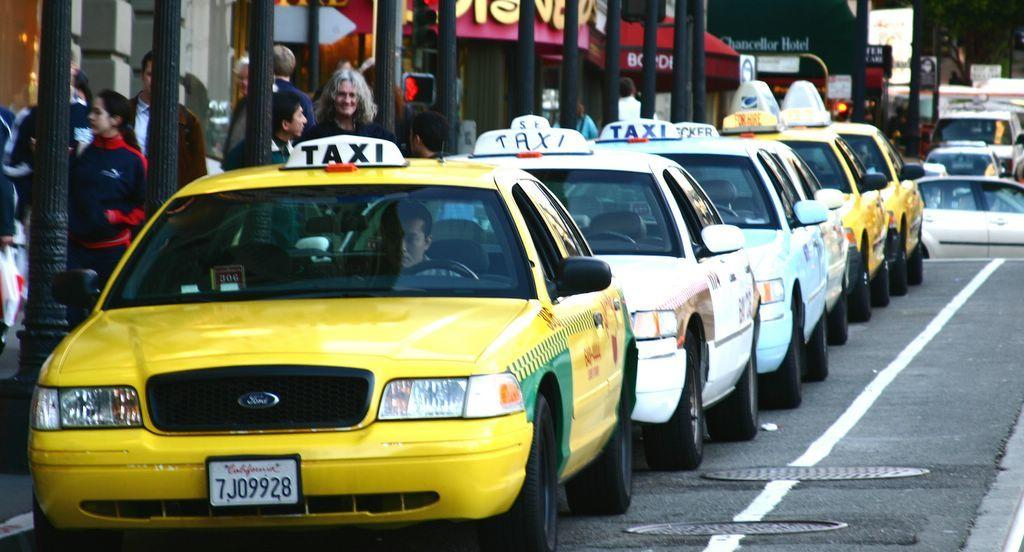<image>
Describe the image concisely. A long line of taxis are parked in front of a Disney Store in New York City. 